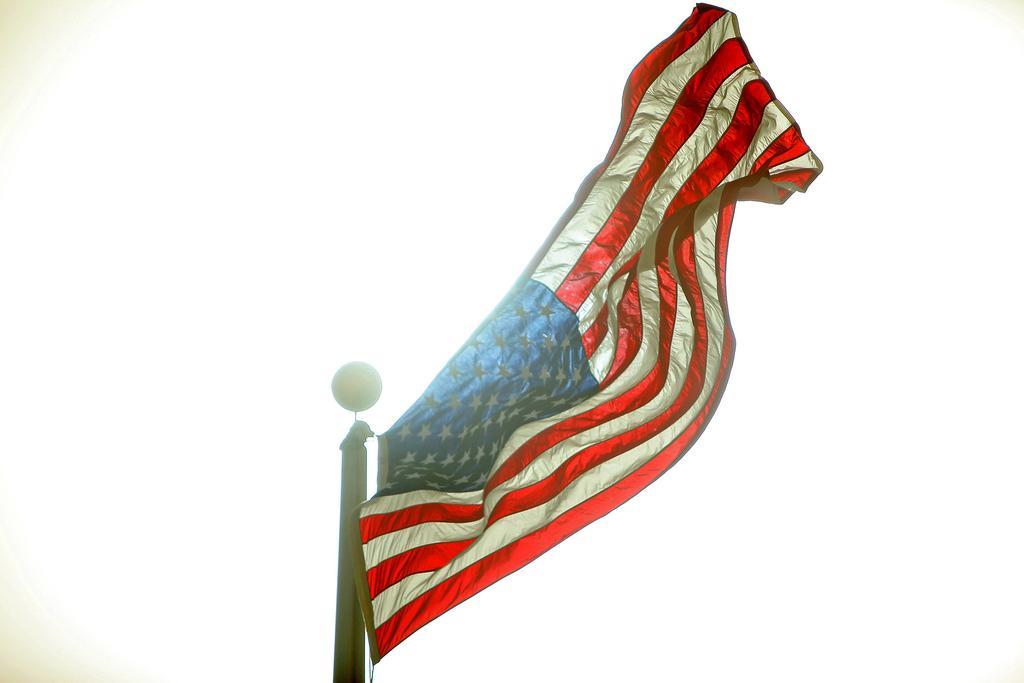What is the main object in the image? There is a flag in the image. What is the flag attached to? The flag is attached to a pole in the image. What is the color of the background in the image? The background of the image is white in color. How does the pancake get washed in the image? There is no pancake present in the image, so it cannot be washed. What type of care is being provided to the flag in the image? The image does not show any specific care being provided to the flag; it simply depicts the flag attached to a pole. 